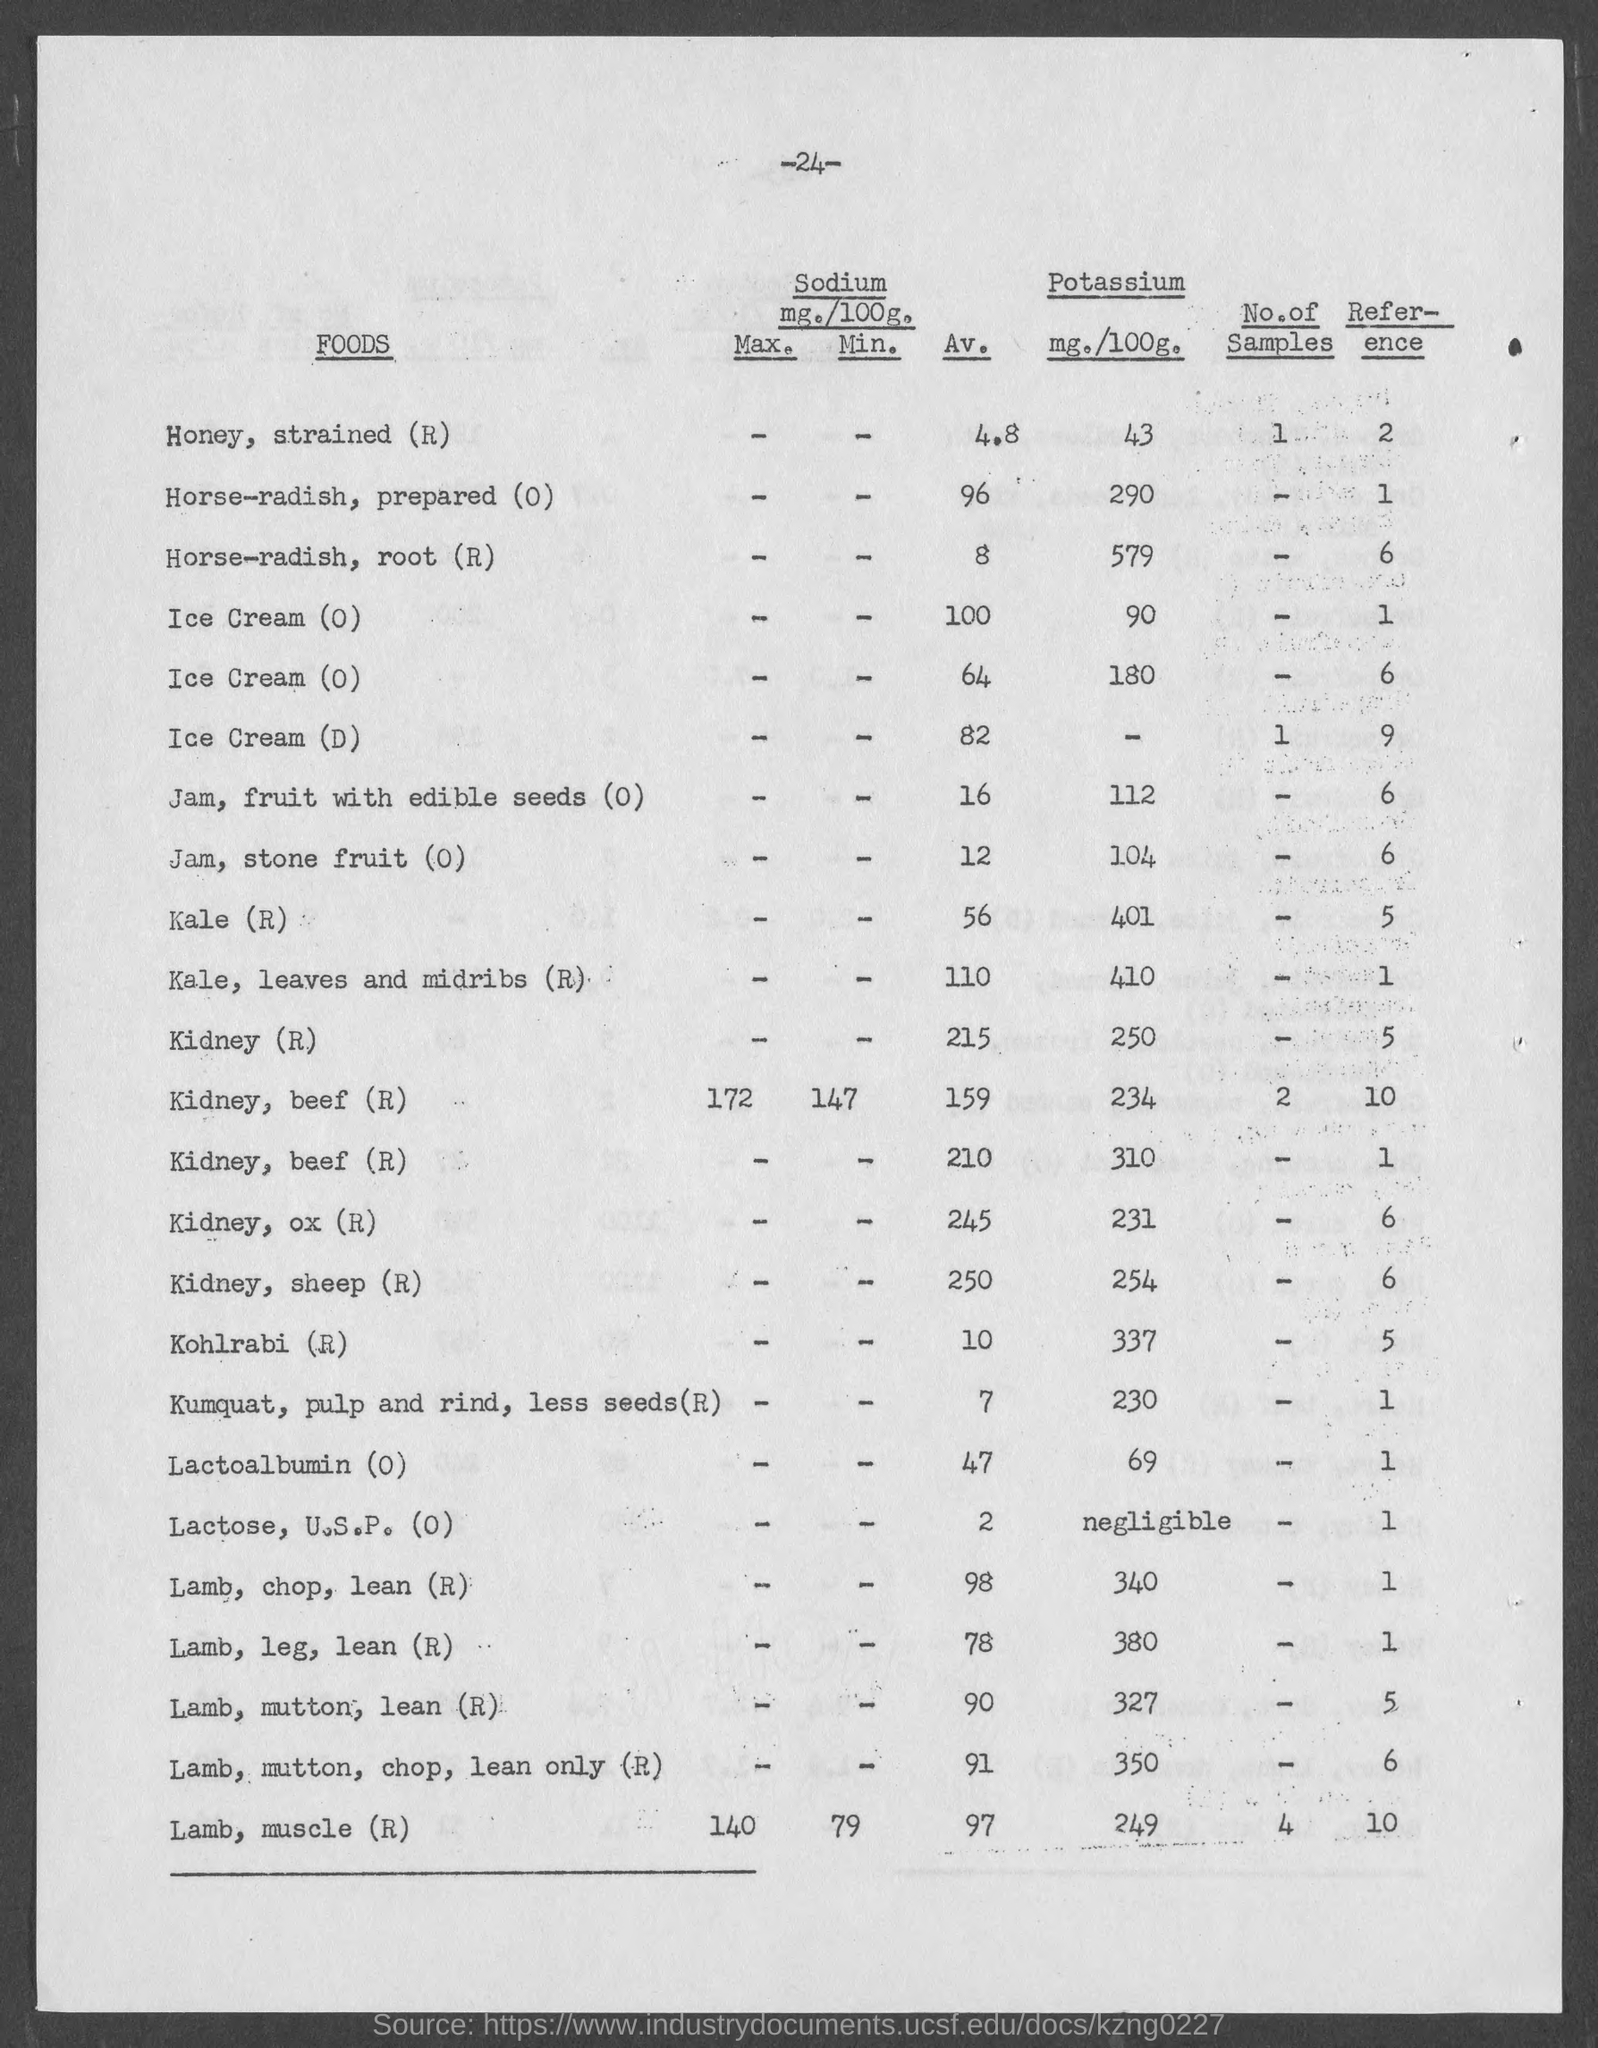How much mg of potassium per 100 grams is contained in honey, strained (R) ?
Provide a succinct answer. 43. How much mg of potassium per 100 grams is contained in Kale (R)?
Ensure brevity in your answer.  401. How much mg of potassium per 100 grams contain in Kohlrabi (R) ?
Give a very brief answer. 337. How much mg of potassium per 100 grams contain in Lactose, U.S.P. (0)?
Offer a terse response. Negligible. 